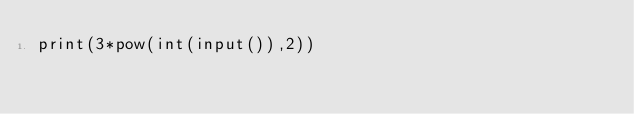<code> <loc_0><loc_0><loc_500><loc_500><_Python_>print(3*pow(int(input()),2))</code> 